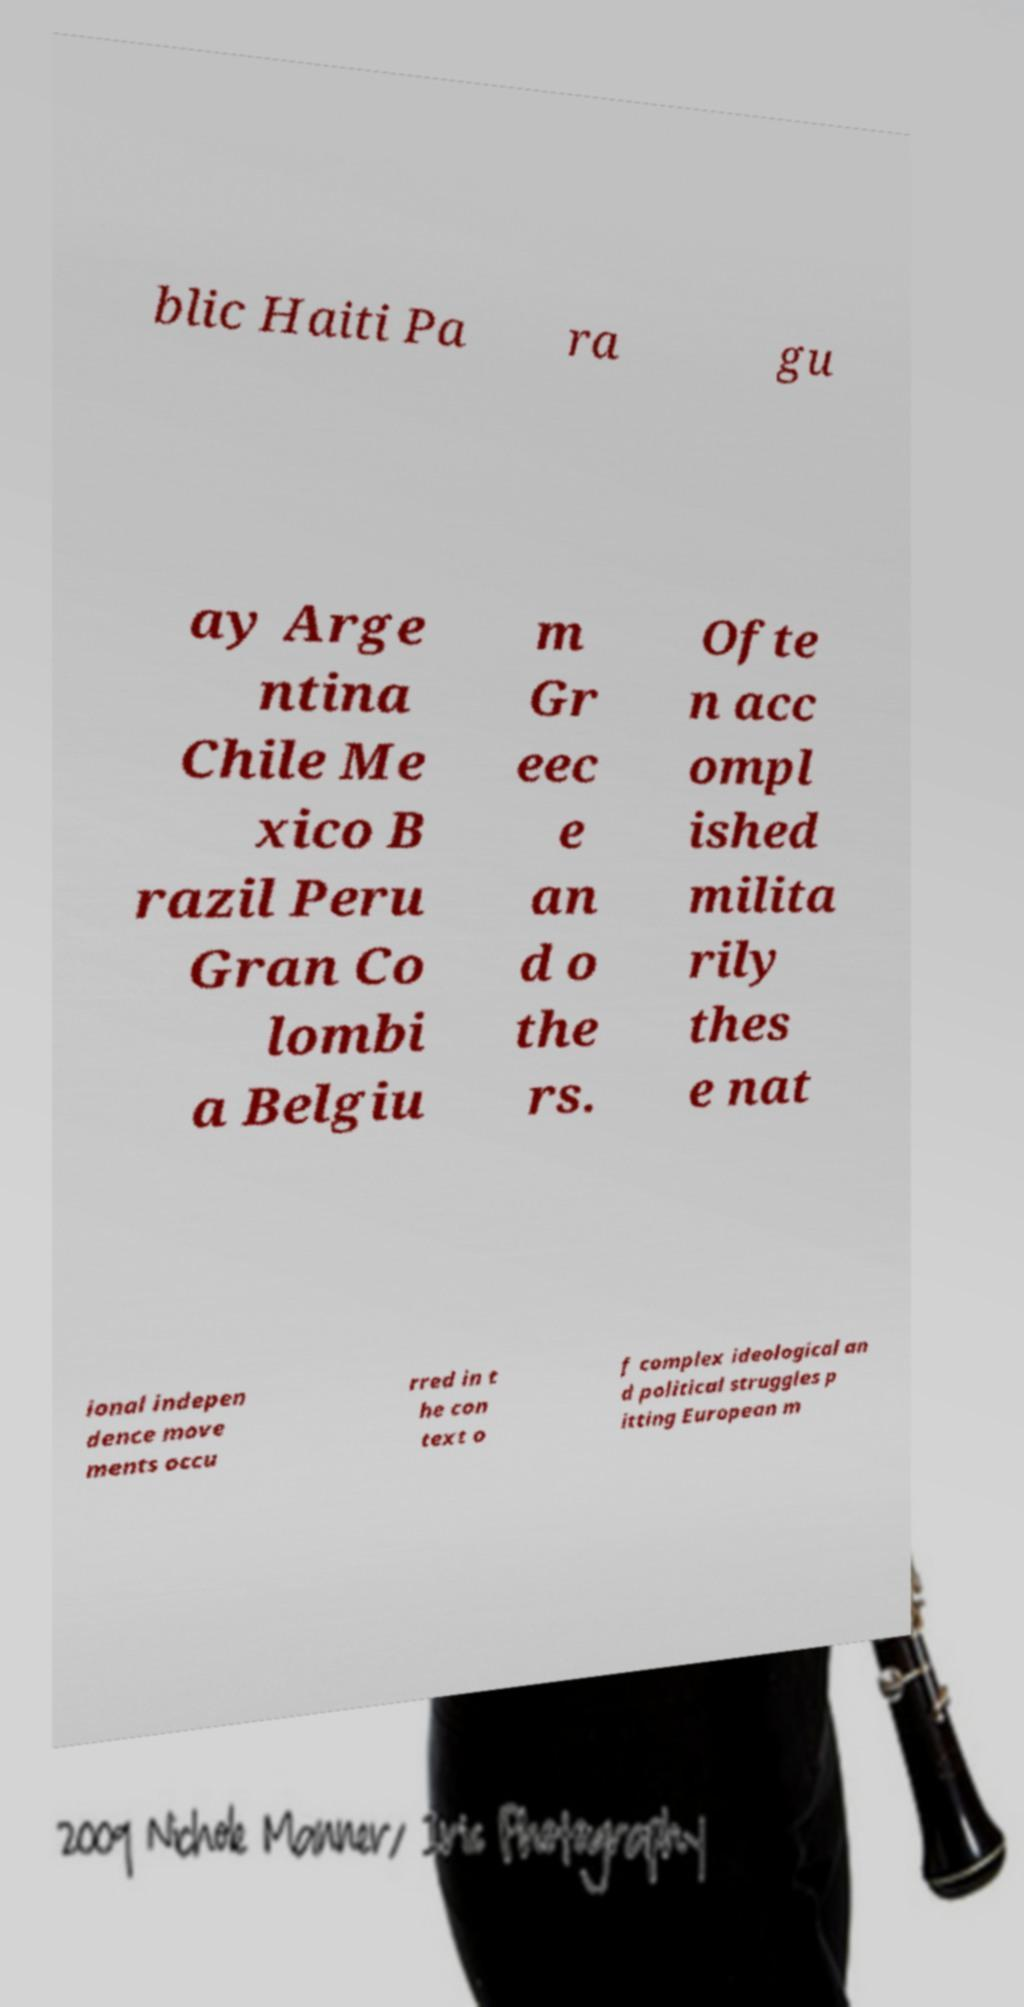Please identify and transcribe the text found in this image. blic Haiti Pa ra gu ay Arge ntina Chile Me xico B razil Peru Gran Co lombi a Belgiu m Gr eec e an d o the rs. Ofte n acc ompl ished milita rily thes e nat ional indepen dence move ments occu rred in t he con text o f complex ideological an d political struggles p itting European m 